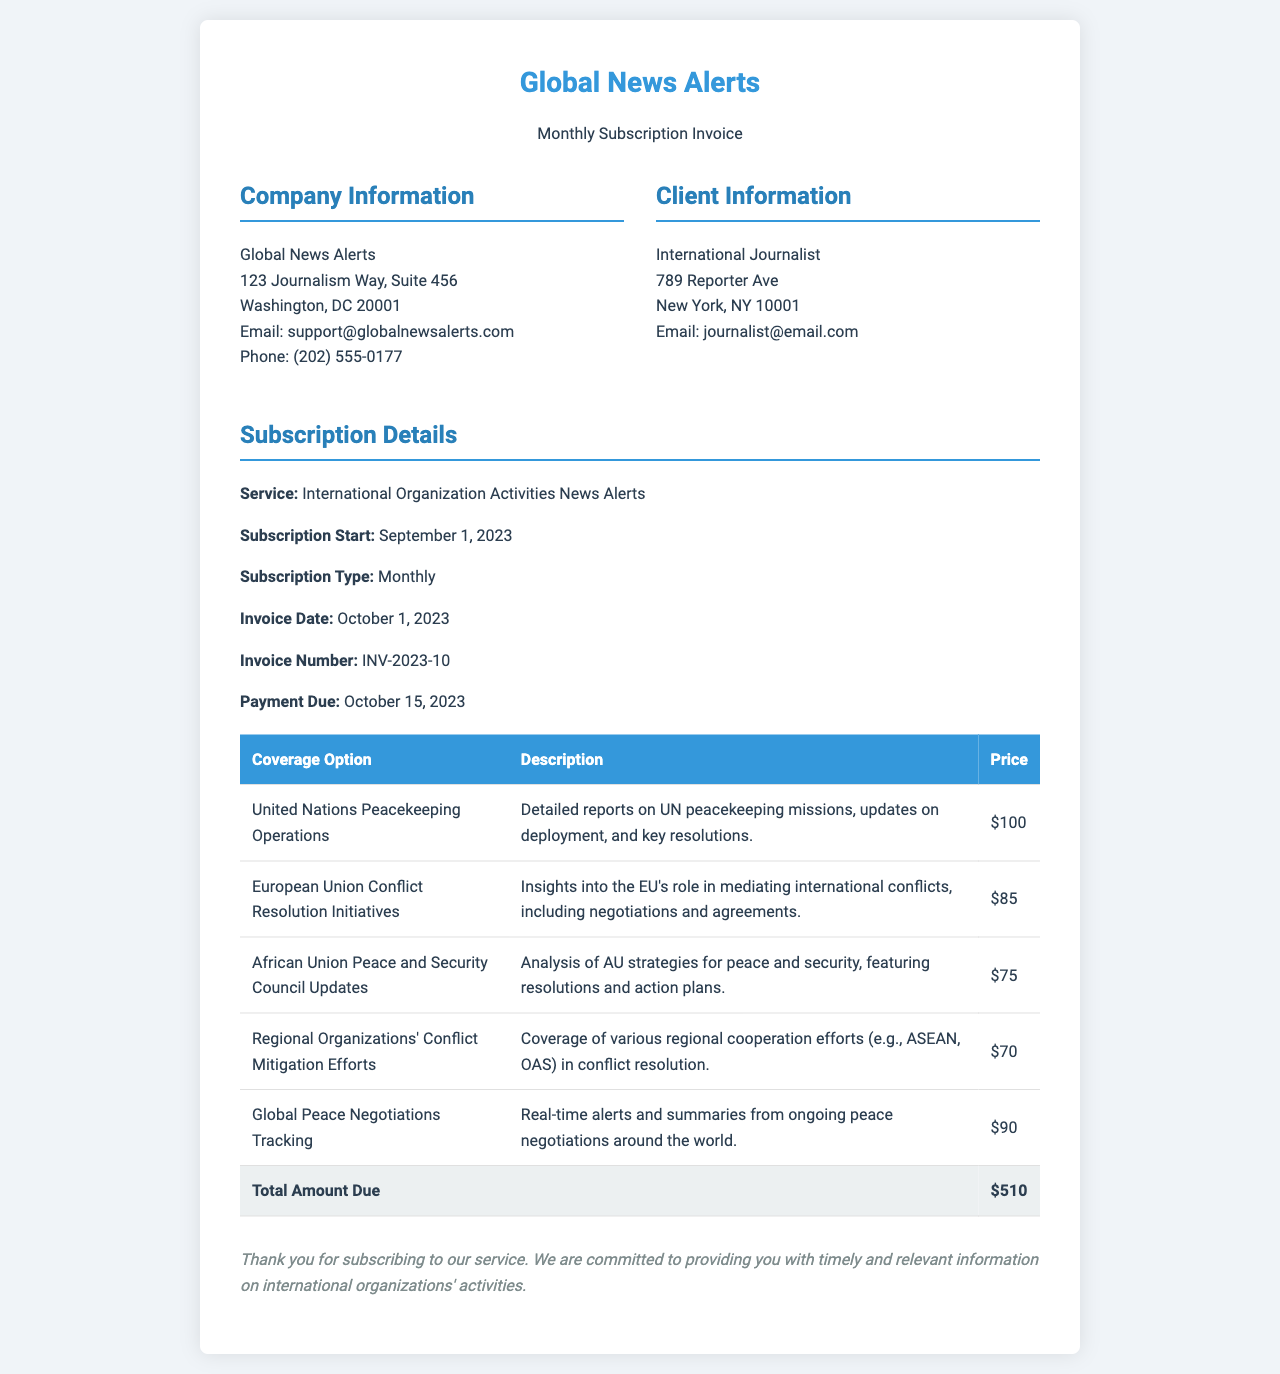What is the service provided? The document specifies that the service provided is "International Organization Activities News Alerts."
Answer: International Organization Activities News Alerts When does the subscription start? The invoice states that the subscription started on "September 1, 2023."
Answer: September 1, 2023 What is the invoice number? The invoice includes the number "INV-2023-10."
Answer: INV-2023-10 What is the total amount due? The total amount due on the invoice is "$510."
Answer: $510 What is the payment due date? The document indicates the payment is due on "October 15, 2023."
Answer: October 15, 2023 How much is the coverage option for United Nations Peacekeeping Operations? The document lists the price for this coverage option as "$100."
Answer: $100 How many coverage options are listed in the document? The total number of coverage options presented in the table is "5."
Answer: 5 What type of document is this? The document is an invoice for a subscription service.
Answer: Invoice What is the company name? The company providing the service is "Global News Alerts."
Answer: Global News Alerts Who is the client? The client listed in the document is "International Journalist."
Answer: International Journalist 